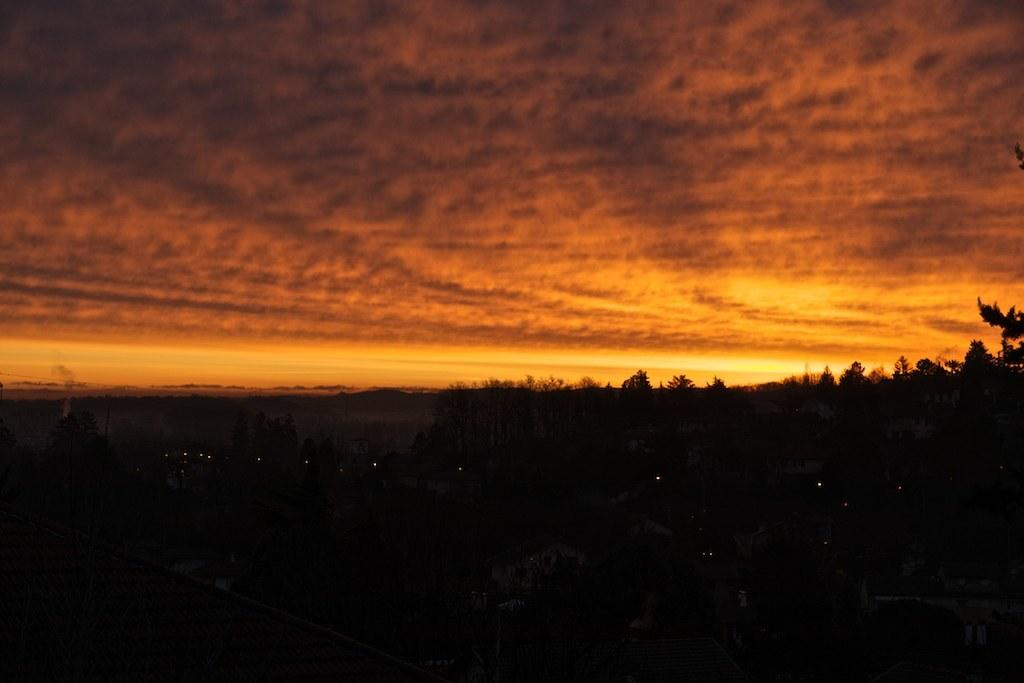What is the overall appearance of the image? The image has a dark appearance. What type of natural elements can be seen in the image? There are trees visible in the image. What part of the natural environment is visible in the image? The sky is visible in the image. What type of plate is being used to serve the holiday meal in the image? There is no plate or holiday meal present in the image; it features a dark appearance with trees and the sky visible. Can you tell me how many horses are grazing in the field in the image? There are no horses or fields present in the image; it features a dark appearance with trees and the sky visible. 